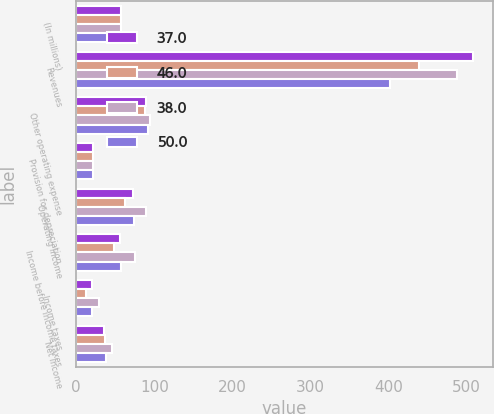Convert chart. <chart><loc_0><loc_0><loc_500><loc_500><stacked_bar_chart><ecel><fcel>(In millions)<fcel>Revenues<fcel>Other operating expense<fcel>Provision for depreciation<fcel>Operating Income<fcel>Income before income taxes<fcel>Income taxes<fcel>Net Income<nl><fcel>37<fcel>57<fcel>508<fcel>89<fcel>22<fcel>73<fcel>56<fcel>20<fcel>36<nl><fcel>46<fcel>57<fcel>439<fcel>88<fcel>22<fcel>63<fcel>49<fcel>12<fcel>37<nl><fcel>38<fcel>57<fcel>487<fcel>95<fcel>22<fcel>90<fcel>75<fcel>29<fcel>46<nl><fcel>50<fcel>57<fcel>402<fcel>92<fcel>22<fcel>74<fcel>58<fcel>20<fcel>38<nl></chart> 